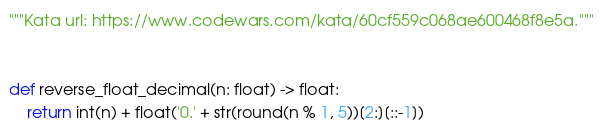<code> <loc_0><loc_0><loc_500><loc_500><_Python_>"""Kata url: https://www.codewars.com/kata/60cf559c068ae600468f8e5a."""


def reverse_float_decimal(n: float) -> float:
    return int(n) + float('0.' + str(round(n % 1, 5))[2:][::-1])
</code> 